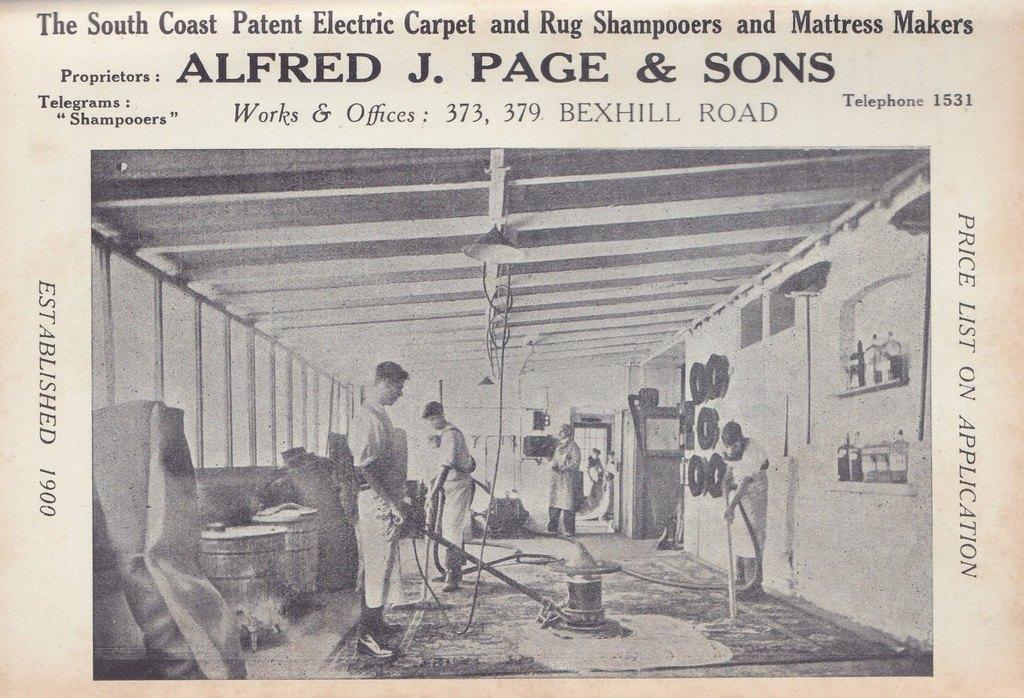Describe this image in one or two sentences. This is a poster and in this poster we can see some people standing on the floor, drums and some objects. 